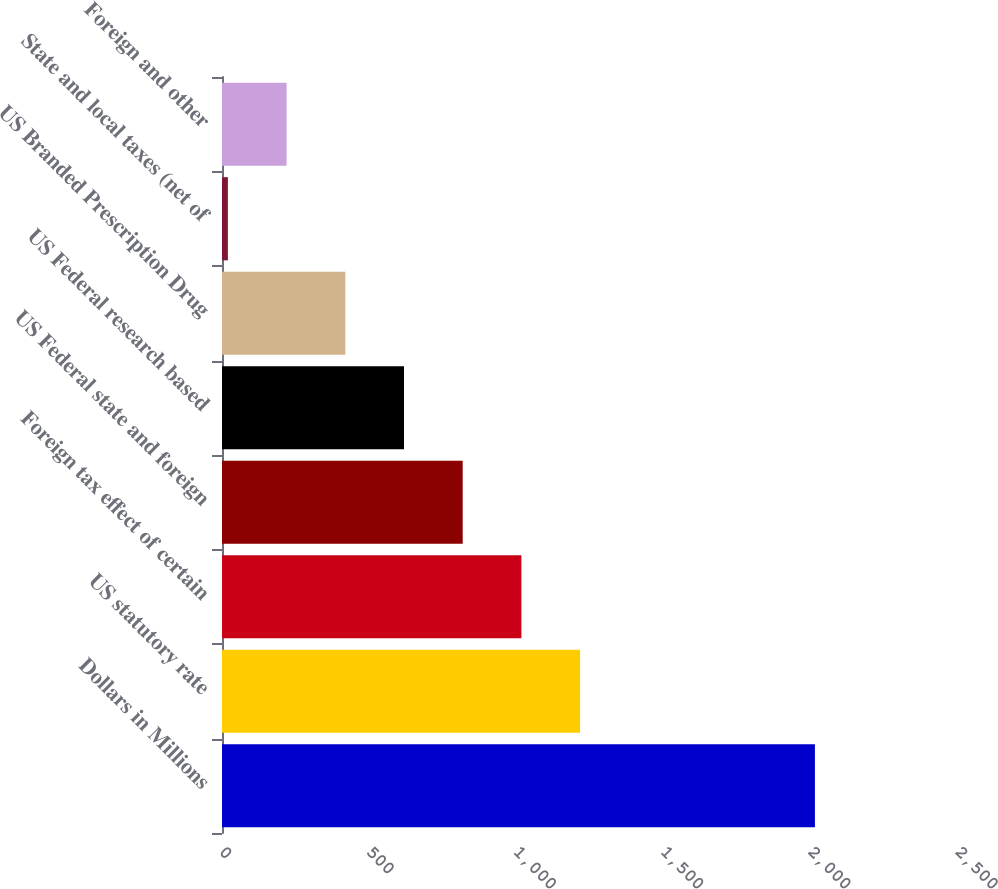Convert chart. <chart><loc_0><loc_0><loc_500><loc_500><bar_chart><fcel>Dollars in Millions<fcel>US statutory rate<fcel>Foreign tax effect of certain<fcel>US Federal state and foreign<fcel>US Federal research based<fcel>US Branded Prescription Drug<fcel>State and local taxes (net of<fcel>Foreign and other<nl><fcel>2014<fcel>1216.4<fcel>1017<fcel>817.6<fcel>618.2<fcel>418.8<fcel>20<fcel>219.4<nl></chart> 